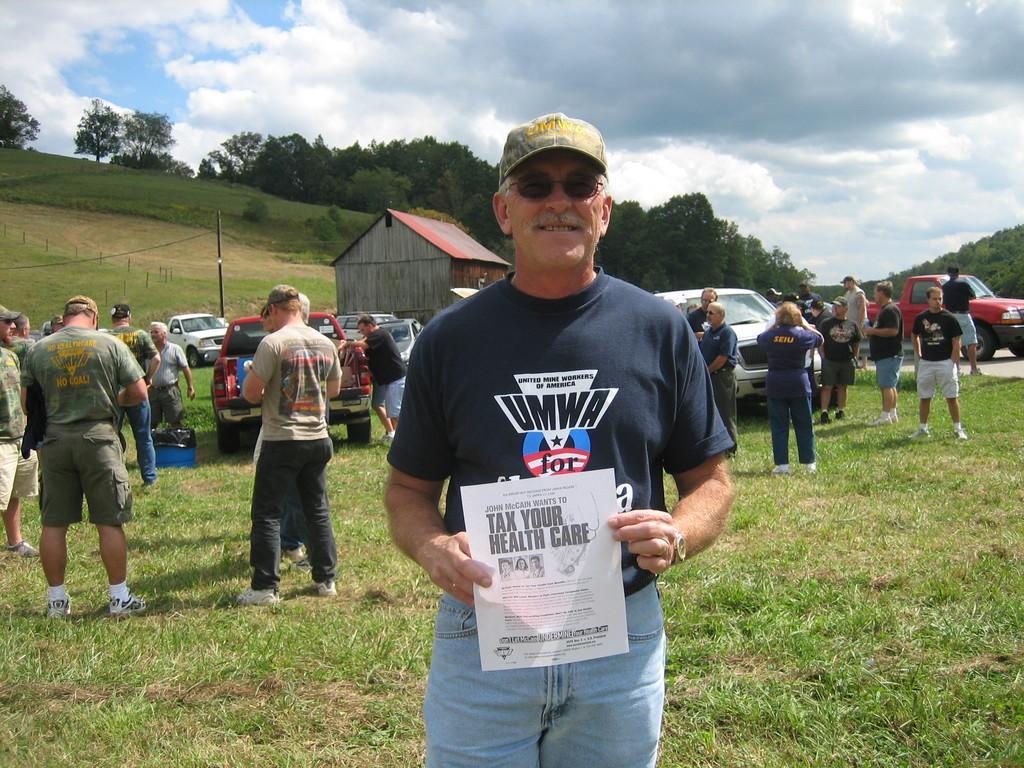Could you give a brief overview of what you see in this image? In this image I can see the group of people and vehicles on the grass. I can see one person holding the paper. In the background I can see the shed, many trees, clouds and the sky. 